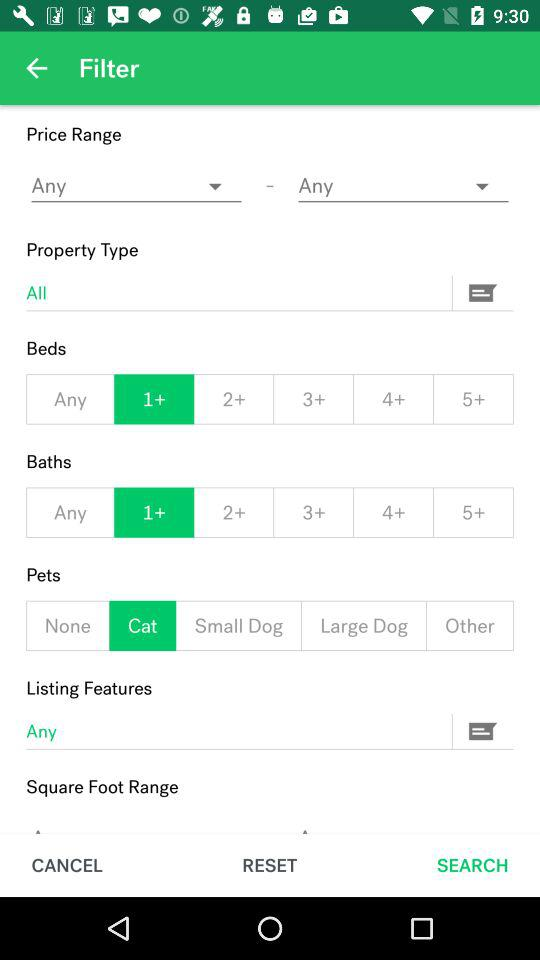What is the number of beds selected? The number of beds selected is 1+. 